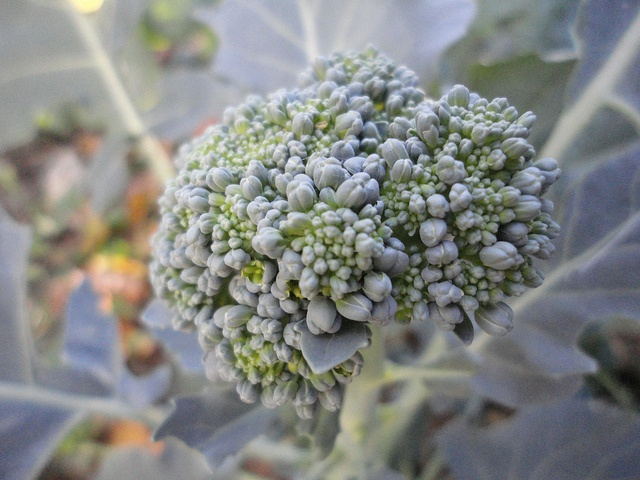Describe the objects in this image and their specific colors. I can see a broccoli in gray, darkgray, lightgray, and black tones in this image. 